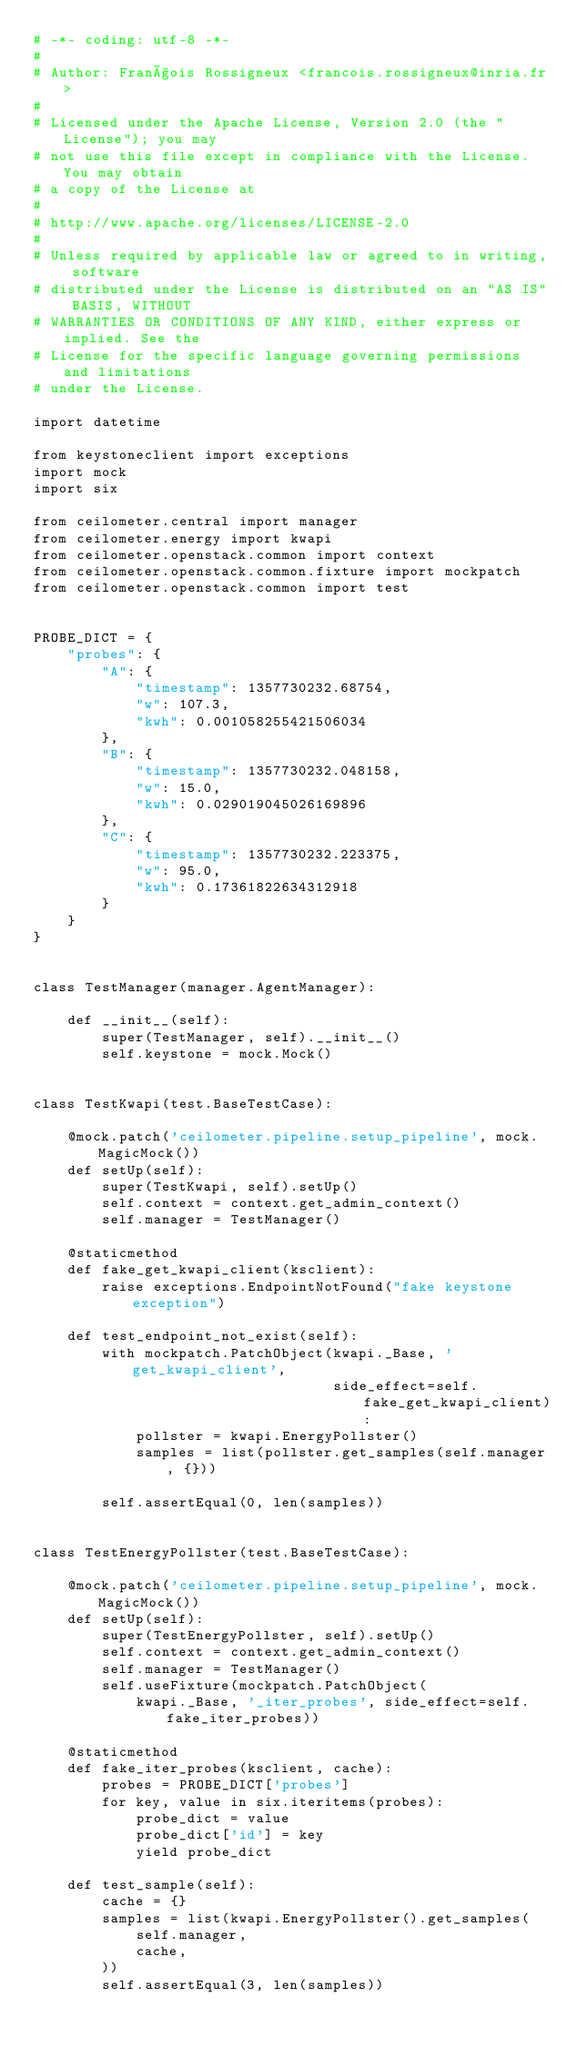Convert code to text. <code><loc_0><loc_0><loc_500><loc_500><_Python_># -*- coding: utf-8 -*-
#
# Author: François Rossigneux <francois.rossigneux@inria.fr>
#
# Licensed under the Apache License, Version 2.0 (the "License"); you may
# not use this file except in compliance with the License. You may obtain
# a copy of the License at
#
# http://www.apache.org/licenses/LICENSE-2.0
#
# Unless required by applicable law or agreed to in writing, software
# distributed under the License is distributed on an "AS IS" BASIS, WITHOUT
# WARRANTIES OR CONDITIONS OF ANY KIND, either express or implied. See the
# License for the specific language governing permissions and limitations
# under the License.

import datetime

from keystoneclient import exceptions
import mock
import six

from ceilometer.central import manager
from ceilometer.energy import kwapi
from ceilometer.openstack.common import context
from ceilometer.openstack.common.fixture import mockpatch
from ceilometer.openstack.common import test


PROBE_DICT = {
    "probes": {
        "A": {
            "timestamp": 1357730232.68754,
            "w": 107.3,
            "kwh": 0.001058255421506034
        },
        "B": {
            "timestamp": 1357730232.048158,
            "w": 15.0,
            "kwh": 0.029019045026169896
        },
        "C": {
            "timestamp": 1357730232.223375,
            "w": 95.0,
            "kwh": 0.17361822634312918
        }
    }
}


class TestManager(manager.AgentManager):

    def __init__(self):
        super(TestManager, self).__init__()
        self.keystone = mock.Mock()


class TestKwapi(test.BaseTestCase):

    @mock.patch('ceilometer.pipeline.setup_pipeline', mock.MagicMock())
    def setUp(self):
        super(TestKwapi, self).setUp()
        self.context = context.get_admin_context()
        self.manager = TestManager()

    @staticmethod
    def fake_get_kwapi_client(ksclient):
        raise exceptions.EndpointNotFound("fake keystone exception")

    def test_endpoint_not_exist(self):
        with mockpatch.PatchObject(kwapi._Base, 'get_kwapi_client',
                                   side_effect=self.fake_get_kwapi_client):
            pollster = kwapi.EnergyPollster()
            samples = list(pollster.get_samples(self.manager, {}))

        self.assertEqual(0, len(samples))


class TestEnergyPollster(test.BaseTestCase):

    @mock.patch('ceilometer.pipeline.setup_pipeline', mock.MagicMock())
    def setUp(self):
        super(TestEnergyPollster, self).setUp()
        self.context = context.get_admin_context()
        self.manager = TestManager()
        self.useFixture(mockpatch.PatchObject(
            kwapi._Base, '_iter_probes', side_effect=self.fake_iter_probes))

    @staticmethod
    def fake_iter_probes(ksclient, cache):
        probes = PROBE_DICT['probes']
        for key, value in six.iteritems(probes):
            probe_dict = value
            probe_dict['id'] = key
            yield probe_dict

    def test_sample(self):
        cache = {}
        samples = list(kwapi.EnergyPollster().get_samples(
            self.manager,
            cache,
        ))
        self.assertEqual(3, len(samples))</code> 